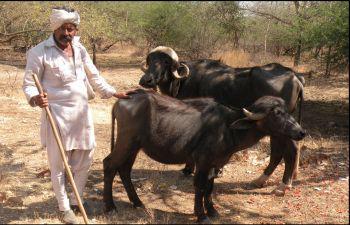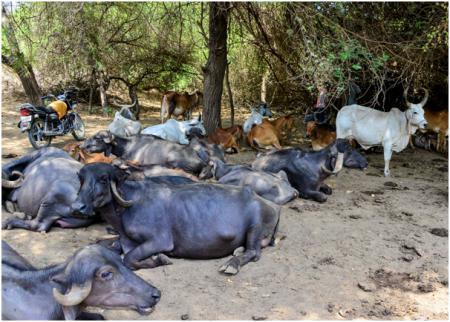The first image is the image on the left, the second image is the image on the right. Considering the images on both sides, is "Two or more humans are visible." valid? Answer yes or no. No. The first image is the image on the left, the second image is the image on the right. Given the left and right images, does the statement "Some animals are laying in mud." hold true? Answer yes or no. Yes. 